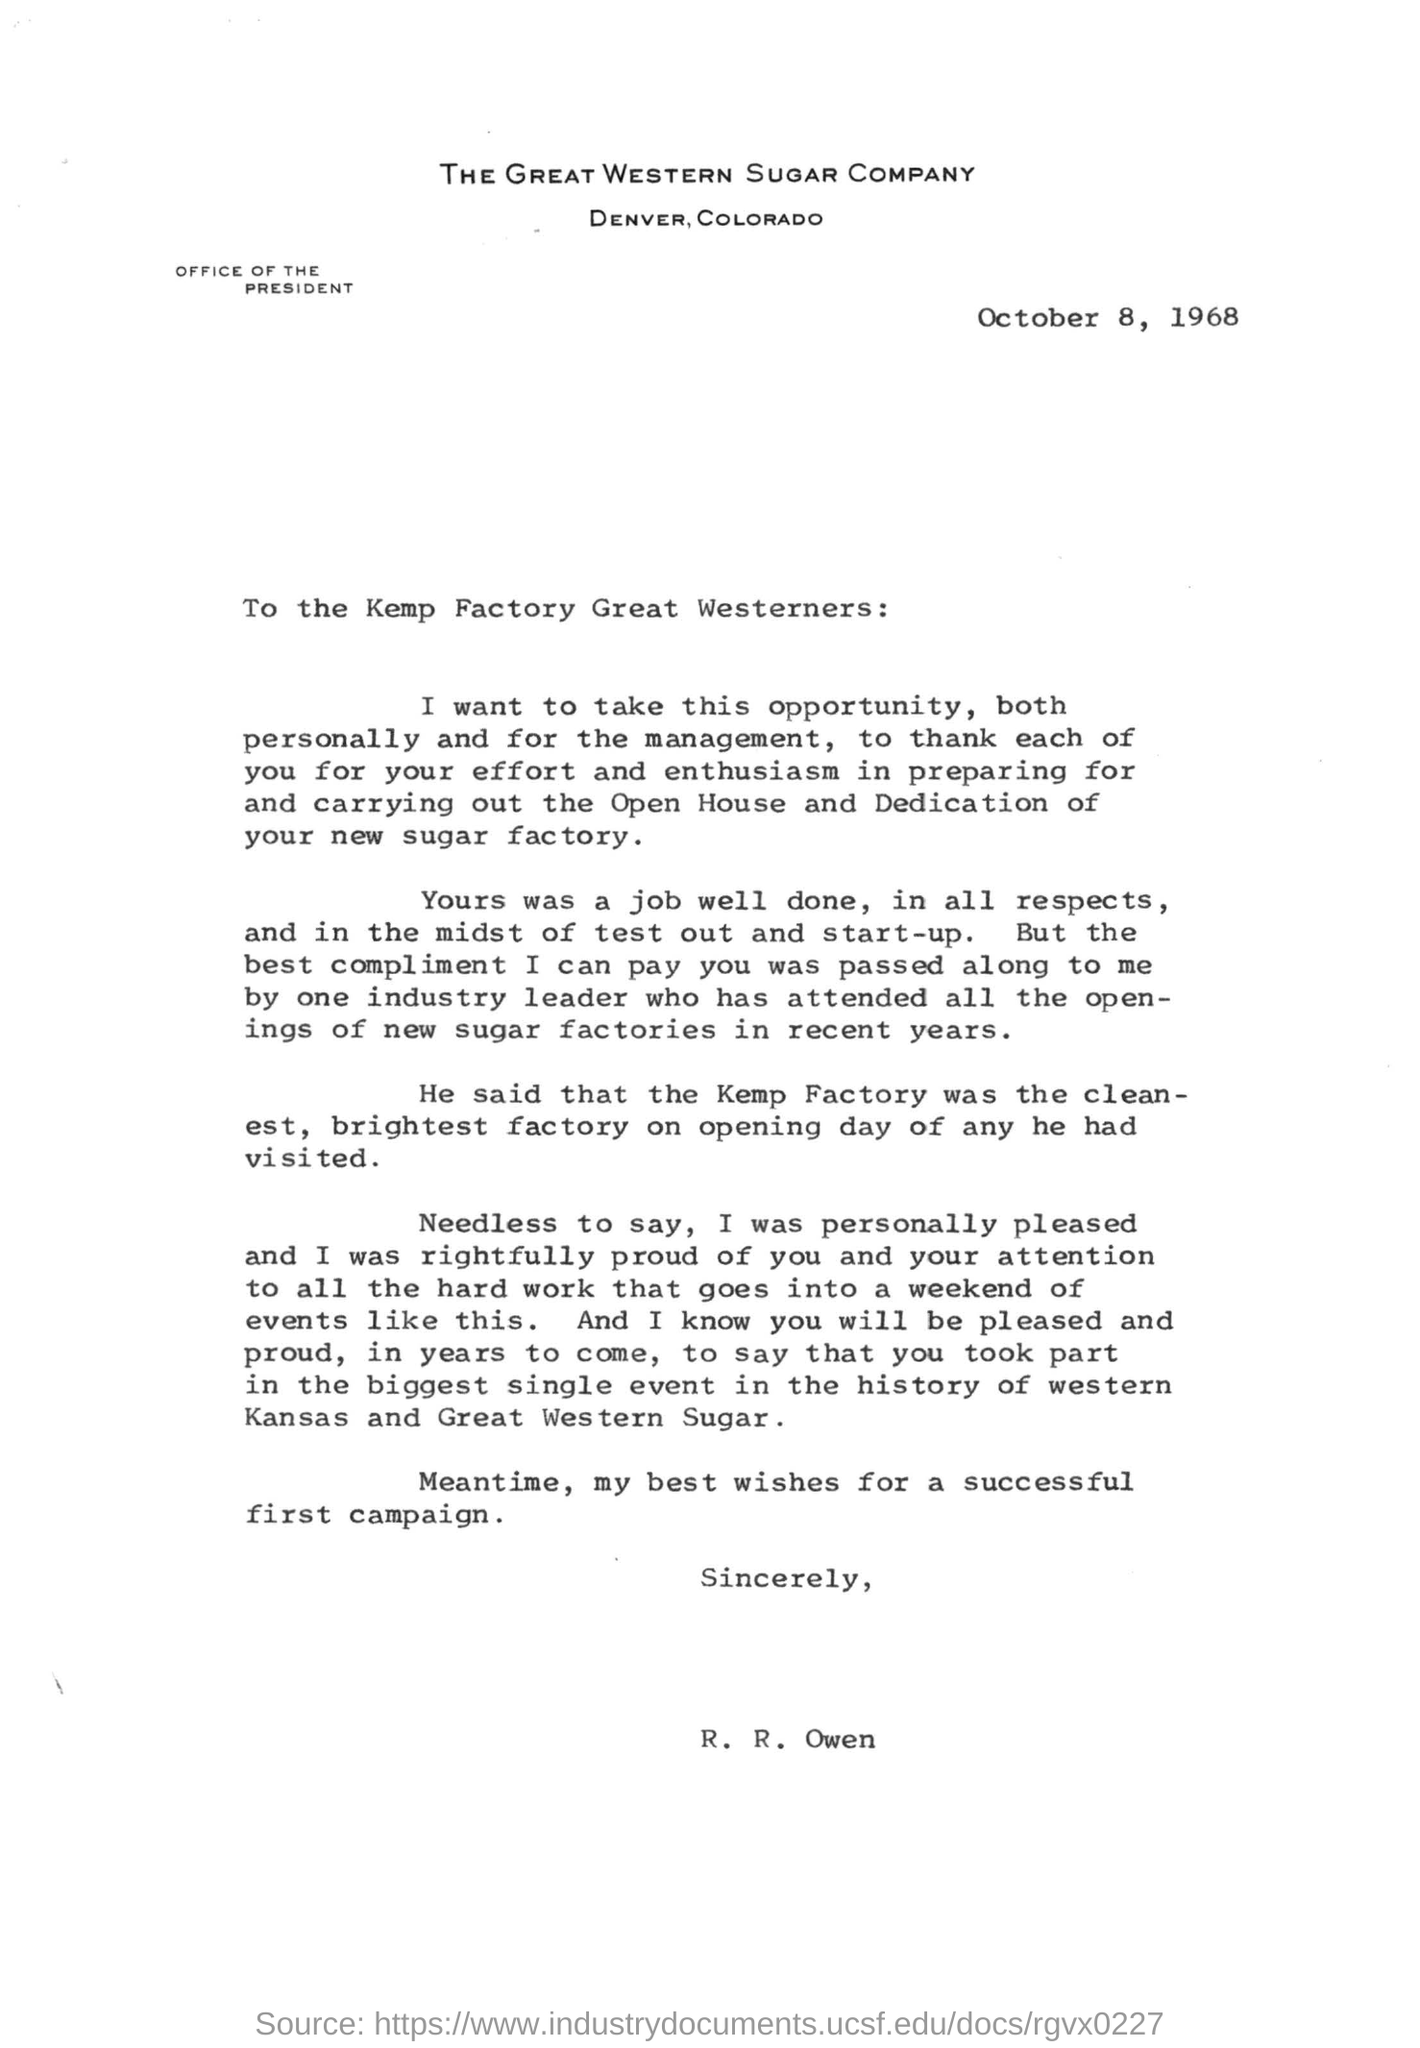List a handful of essential elements in this visual. The letter was written by R. R. Owen. The letter is dated October 8, 1968. The name of the factory is Kemp. 